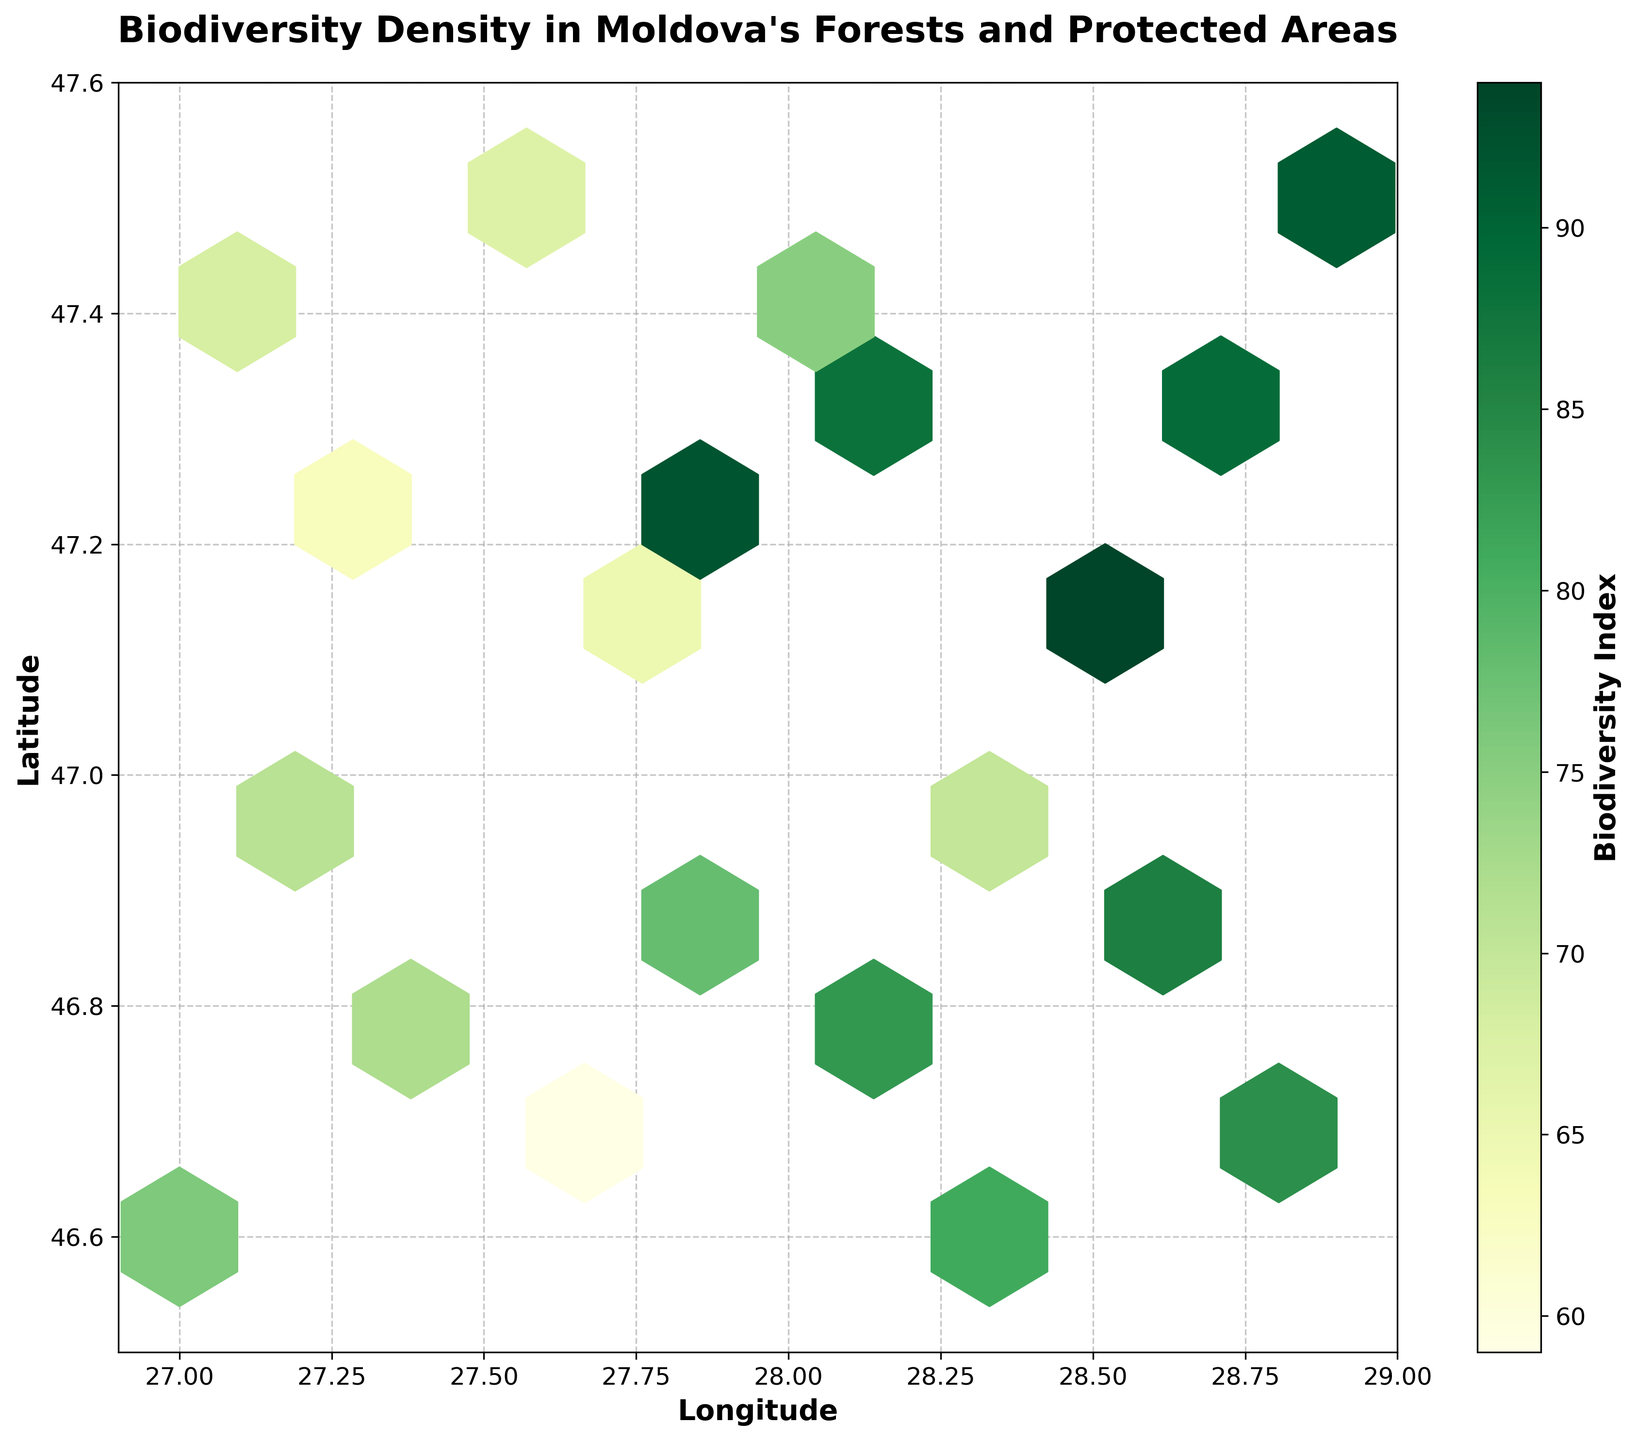What is the title of the figure? The title of a figure is typically provided at the top center, and in this case, it indicates the main subject of the plot. The title here is likely to be descriptive of the contents.
Answer: Biodiversity Density in Moldova's Forests and Protected Areas What colors are used to represent the biodiversity index? The color representation can usually be determined by looking at the color bar on the side of the plot. Here, it uses a color range from light to dark shades of green.
Answer: Shades of green What is the range of longitude values on the x-axis? The x-axis labels indicate the range of longitude values over which the data is spread. The figure should provide this information at the bottom.
Answer: 26.9 to 29.0 What is the average biodiversity index value of the hexbin plot? To find the average, identify the color bar values and locate regions with similar shades. Then approximate the average index value by considering the most frequent shades.
Answer: Approximately 75 Which region (latitude and longitude) has the highest biodiversity index? The highest value can be found by identifying the darkest green shade on the plot and noting its position.
Answer: Around (27.5, 47.1) What is the difference in biodiversity index between the latitudes 46.8 and 47.2? Locate the average shades of green at latitudes 46.8 and 47.2, interpret their values from the color bar, and subtract the lower from the higher.
Answer: Approximately 20 (72 at 46.8; 92 at 47.2) Does the biodiversity index appear to be higher in the forested areas or protected areas? Observing the distributions, correlate the hexbin plot locations with known forested and protected areas, and compare their colors (index values).
Answer: Higher in protected areas Which grid cells have at least one data point? Hexbin plots darken in areas where at least one datapoint is present. Identify and count the filled hexagons.
Answer: Almost all grid cells How does the biodiversity index vary with increasing latitude? Assess the trend in color shades from lower to higher latitudes to interpret how the index changes.
Answer: Generally increases Is there any noticeable trend in biodiversity index with respect to longitude? Examine the variation in shades from the left to the right of the plot, correlating with longitude.
Answer: No obvious trend 